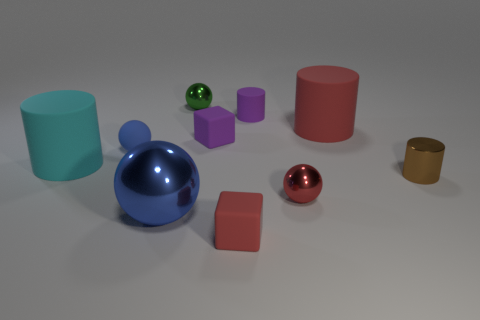Subtract all large balls. How many balls are left? 3 Subtract 2 cylinders. How many cylinders are left? 2 Subtract all purple cubes. How many cubes are left? 1 Add 8 tiny brown metallic objects. How many tiny brown metallic objects exist? 9 Subtract 1 brown cylinders. How many objects are left? 9 Subtract all balls. How many objects are left? 6 Subtract all green spheres. Subtract all red blocks. How many spheres are left? 3 Subtract all purple blocks. How many green cylinders are left? 0 Subtract all purple shiny objects. Subtract all tiny metallic spheres. How many objects are left? 8 Add 3 tiny brown cylinders. How many tiny brown cylinders are left? 4 